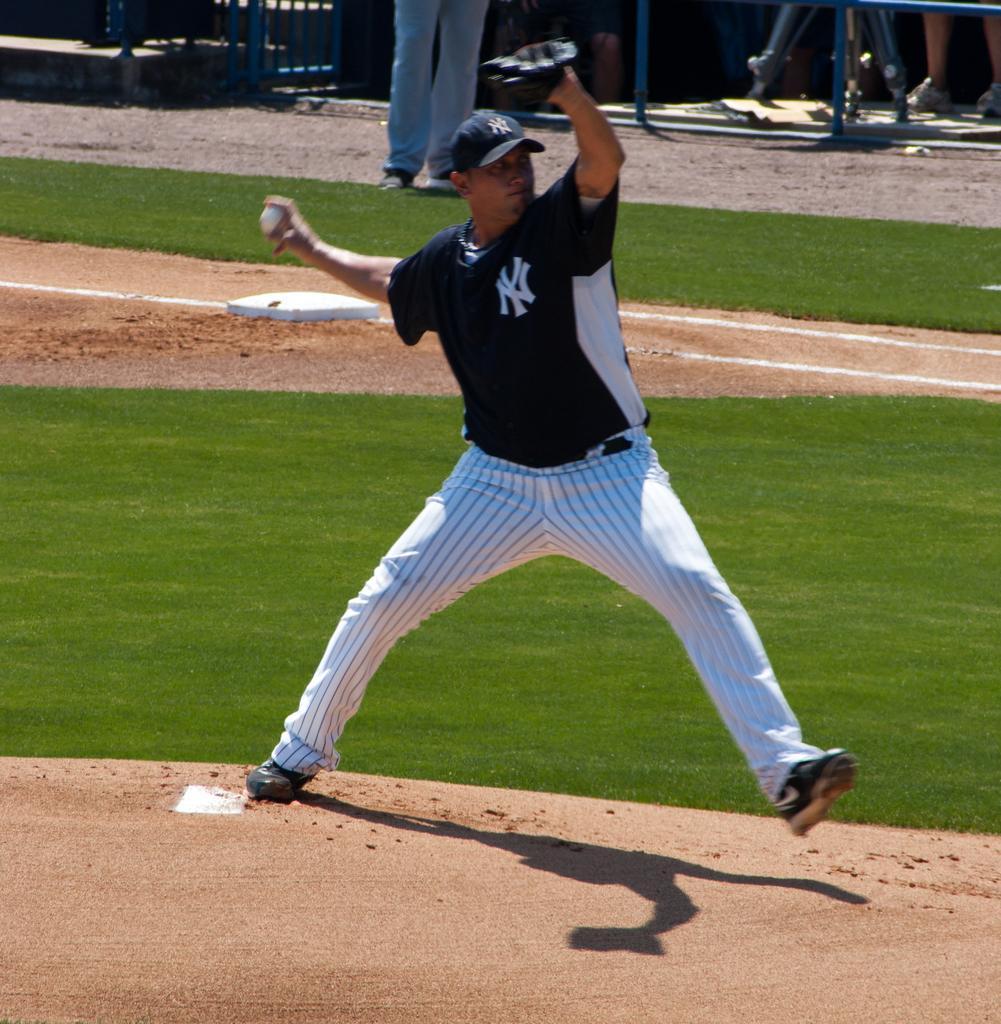How would you summarize this image in a sentence or two? In this image there is a playground, there is a person holding a ball, there are persons truncated towards the top of the image, there are objects truncated towards the top of the image, there is grass truncated. 